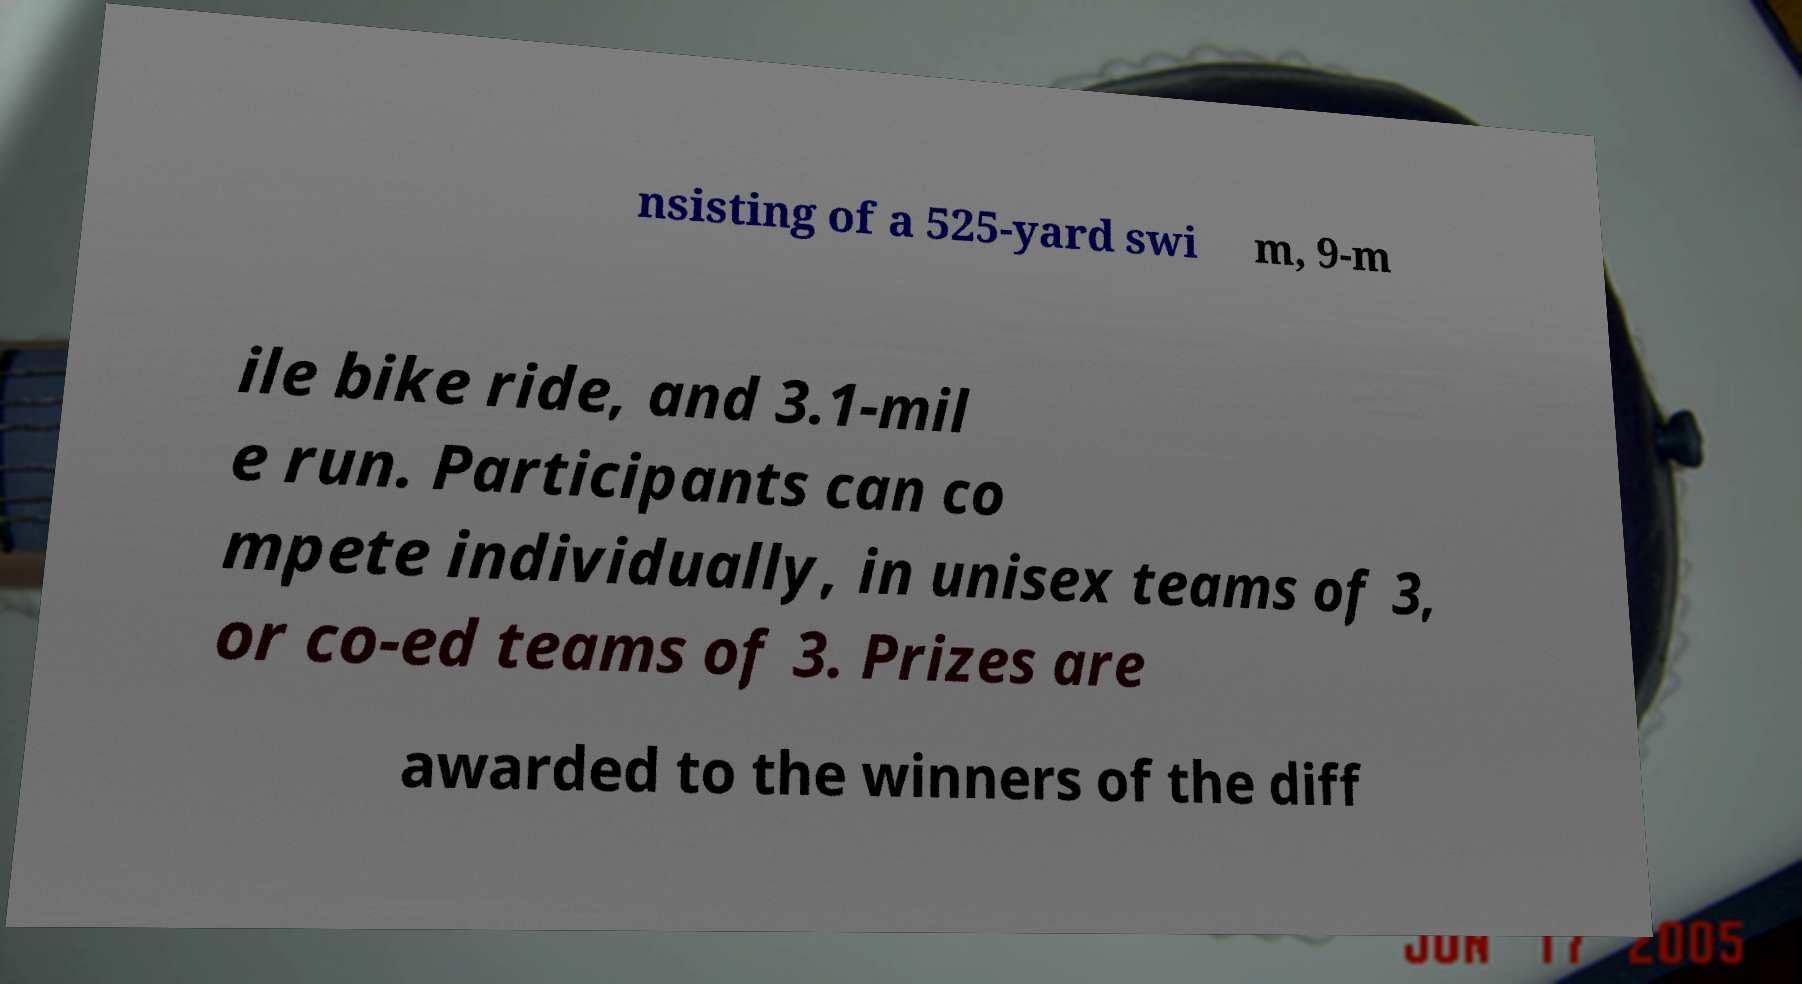Could you extract and type out the text from this image? nsisting of a 525-yard swi m, 9-m ile bike ride, and 3.1-mil e run. Participants can co mpete individually, in unisex teams of 3, or co-ed teams of 3. Prizes are awarded to the winners of the diff 